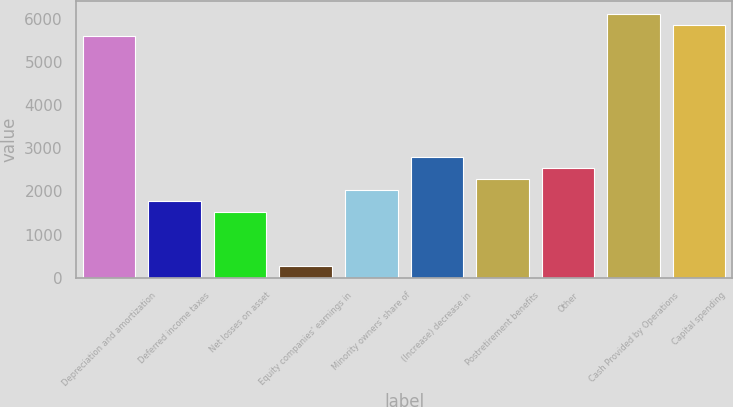<chart> <loc_0><loc_0><loc_500><loc_500><bar_chart><fcel>Depreciation and amortization<fcel>Deferred income taxes<fcel>Net losses on asset<fcel>Equity companies' earnings in<fcel>Minority owners' share of<fcel>(Increase) decrease in<fcel>Postretirement benefits<fcel>Other<fcel>Cash Provided by Operations<fcel>Capital spending<nl><fcel>5605.72<fcel>1788.82<fcel>1534.36<fcel>262.06<fcel>2043.28<fcel>2806.66<fcel>2297.74<fcel>2552.2<fcel>6114.64<fcel>5860.18<nl></chart> 